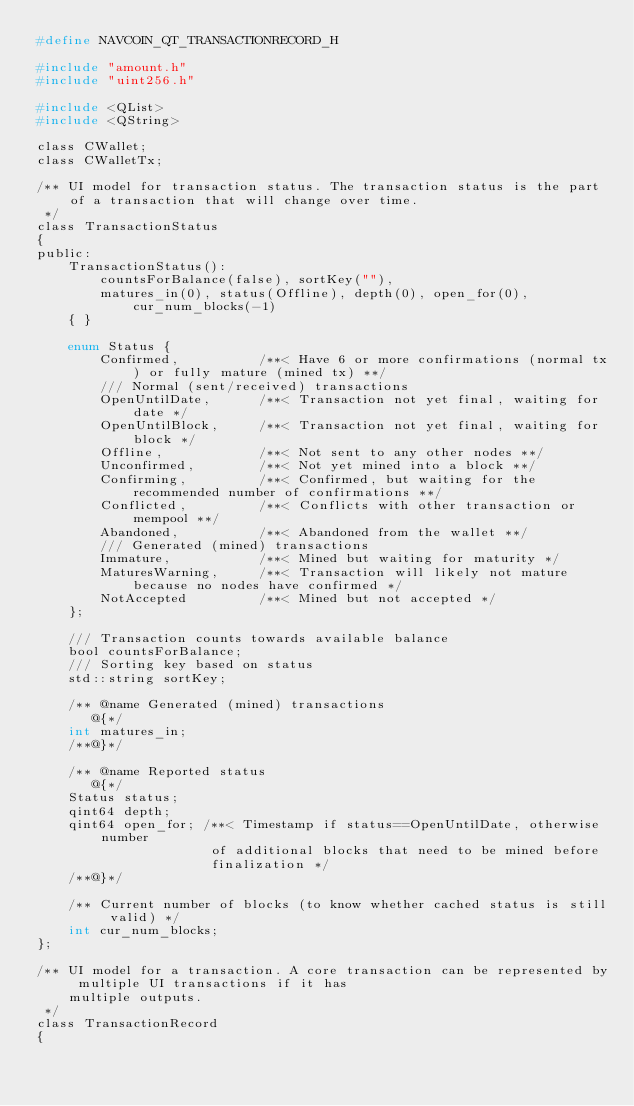<code> <loc_0><loc_0><loc_500><loc_500><_C_>#define NAVCOIN_QT_TRANSACTIONRECORD_H

#include "amount.h"
#include "uint256.h"

#include <QList>
#include <QString>

class CWallet;
class CWalletTx;

/** UI model for transaction status. The transaction status is the part of a transaction that will change over time.
 */
class TransactionStatus
{
public:
    TransactionStatus():
        countsForBalance(false), sortKey(""),
        matures_in(0), status(Offline), depth(0), open_for(0), cur_num_blocks(-1)
    { }

    enum Status {
        Confirmed,          /**< Have 6 or more confirmations (normal tx) or fully mature (mined tx) **/
        /// Normal (sent/received) transactions
        OpenUntilDate,      /**< Transaction not yet final, waiting for date */
        OpenUntilBlock,     /**< Transaction not yet final, waiting for block */
        Offline,            /**< Not sent to any other nodes **/
        Unconfirmed,        /**< Not yet mined into a block **/
        Confirming,         /**< Confirmed, but waiting for the recommended number of confirmations **/
        Conflicted,         /**< Conflicts with other transaction or mempool **/
        Abandoned,          /**< Abandoned from the wallet **/
        /// Generated (mined) transactions
        Immature,           /**< Mined but waiting for maturity */
        MaturesWarning,     /**< Transaction will likely not mature because no nodes have confirmed */
        NotAccepted         /**< Mined but not accepted */
    };

    /// Transaction counts towards available balance
    bool countsForBalance;
    /// Sorting key based on status
    std::string sortKey;

    /** @name Generated (mined) transactions
       @{*/
    int matures_in;
    /**@}*/

    /** @name Reported status
       @{*/
    Status status;
    qint64 depth;
    qint64 open_for; /**< Timestamp if status==OpenUntilDate, otherwise number
                      of additional blocks that need to be mined before
                      finalization */
    /**@}*/

    /** Current number of blocks (to know whether cached status is still valid) */
    int cur_num_blocks;
};

/** UI model for a transaction. A core transaction can be represented by multiple UI transactions if it has
    multiple outputs.
 */
class TransactionRecord
{</code> 